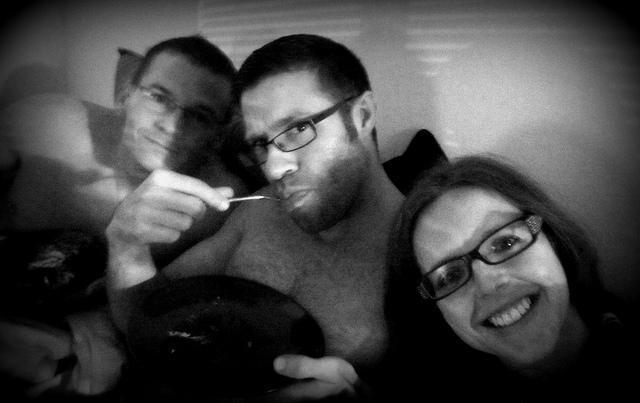What is a good word to describe all of these people?
Answer the question by selecting the correct answer among the 4 following choices.
Options: Toddlers, women, bespectacled, senior citizens. Bespectacled. 